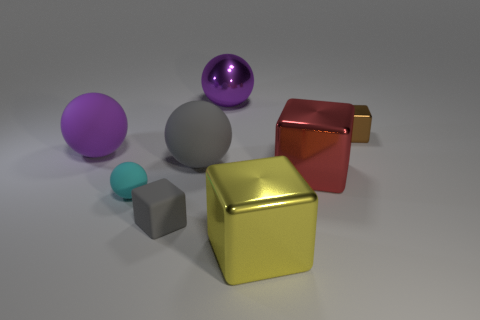Is the material of the large block behind the gray cube the same as the cyan sphere? No, the large block behind the gray cube appears to have a metallic and reflective surface, similar to the gold and red cubes in appearance, while the cyan sphere has a matte finish with less reflectivity, indicating that the materials are not the same. 